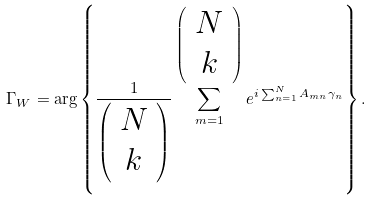<formula> <loc_0><loc_0><loc_500><loc_500>\Gamma _ { W } = \arg \left \{ \frac { 1 } { \left ( \begin{array} { c } N \\ k \\ \end{array} \right ) } \sum _ { m = 1 } ^ { \left ( \begin{array} { c } N \\ k \\ \end{array} \right ) } e ^ { i \sum _ { n = 1 } ^ { N } A _ { m n } \gamma _ { n } } \right \} .</formula> 